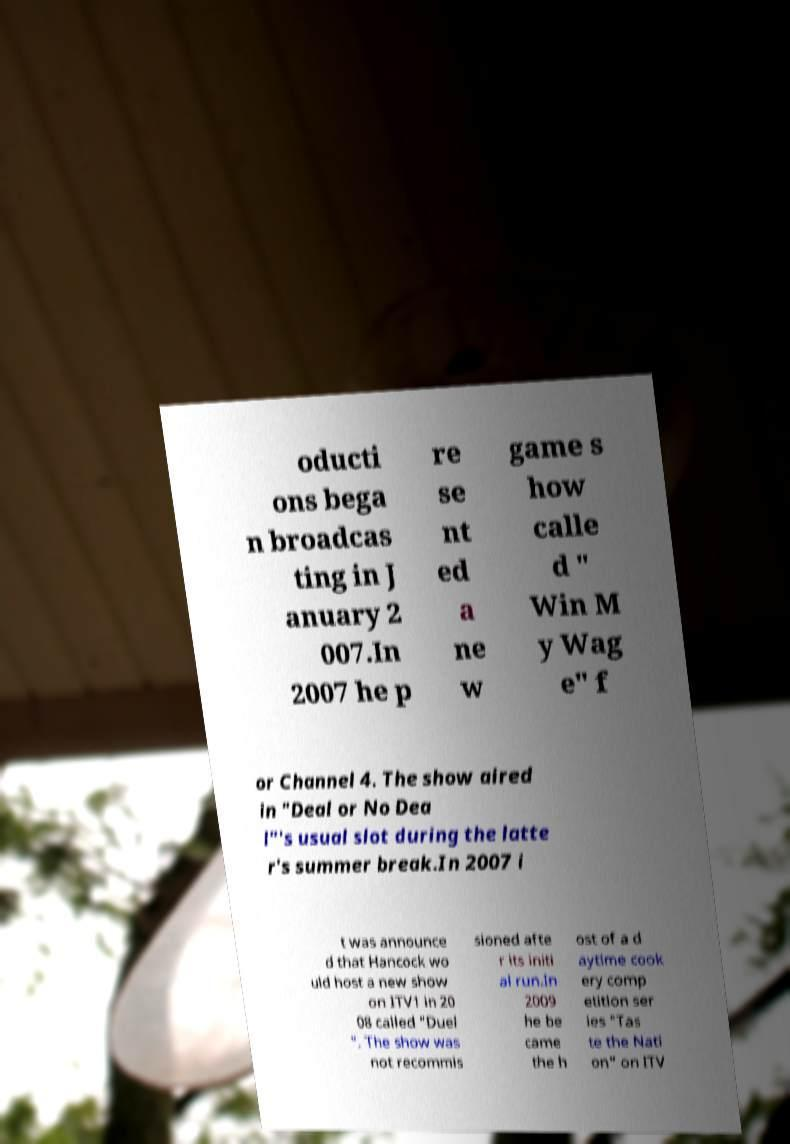Could you extract and type out the text from this image? oducti ons bega n broadcas ting in J anuary 2 007.In 2007 he p re se nt ed a ne w game s how calle d " Win M y Wag e" f or Channel 4. The show aired in "Deal or No Dea l"'s usual slot during the latte r's summer break.In 2007 i t was announce d that Hancock wo uld host a new show on ITV1 in 20 08 called "Duel ". The show was not recommis sioned afte r its initi al run.In 2009 he be came the h ost of a d aytime cook ery comp etition ser ies "Tas te the Nati on" on ITV 